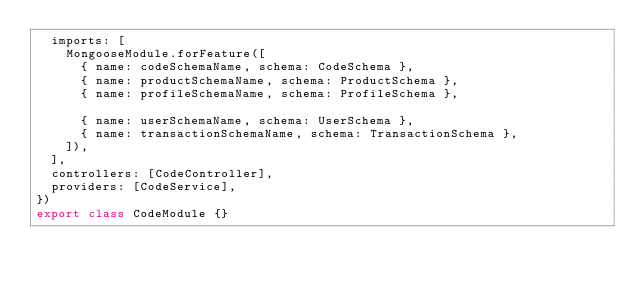Convert code to text. <code><loc_0><loc_0><loc_500><loc_500><_TypeScript_>  imports: [
    MongooseModule.forFeature([
      { name: codeSchemaName, schema: CodeSchema },
      { name: productSchemaName, schema: ProductSchema },
      { name: profileSchemaName, schema: ProfileSchema },

      { name: userSchemaName, schema: UserSchema },
      { name: transactionSchemaName, schema: TransactionSchema },
    ]),
  ],
  controllers: [CodeController],
  providers: [CodeService],
})
export class CodeModule {}
</code> 